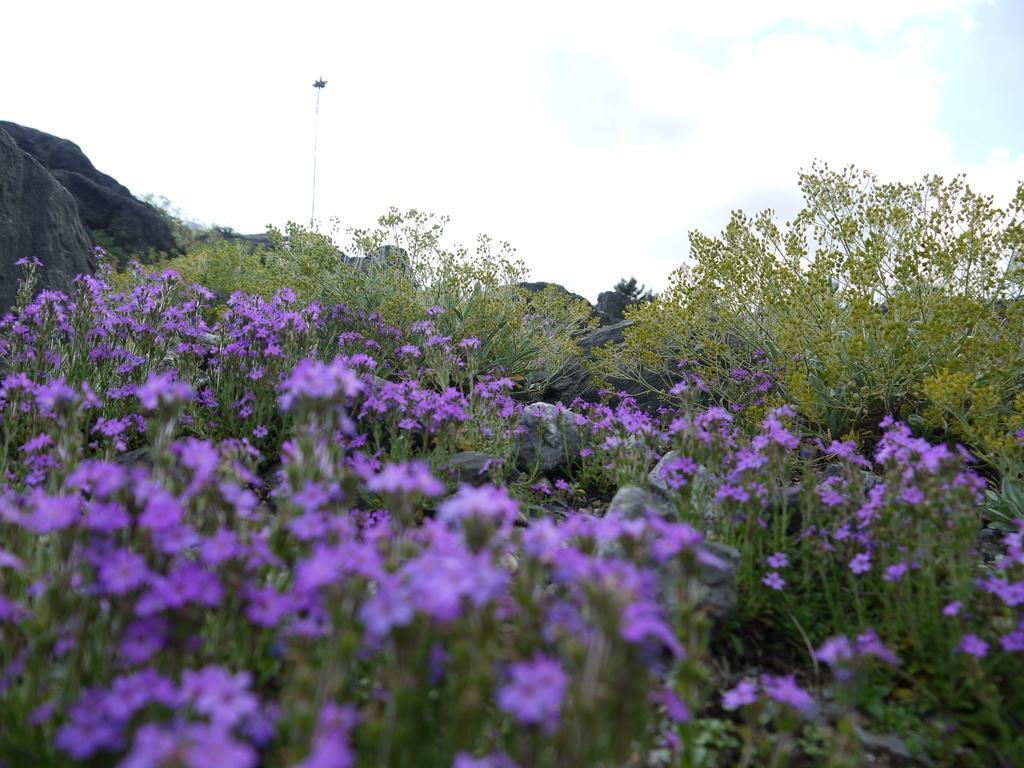How would you summarize this image in a sentence or two? In this image in front there are plants and flowers. In the background of the image there are rocks and sky. 